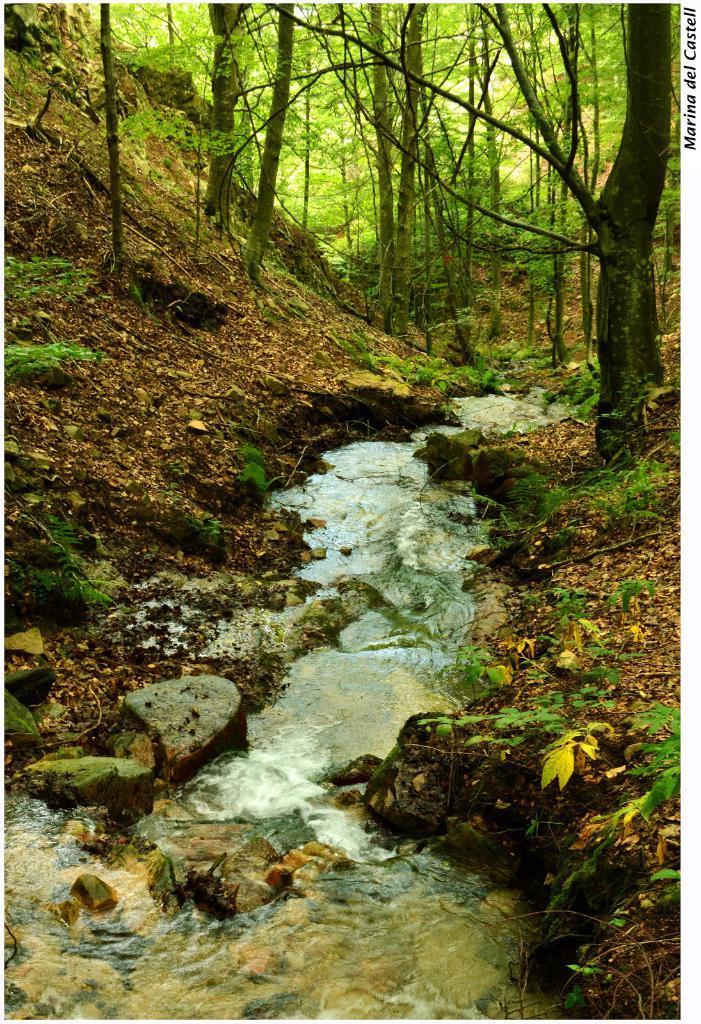Please provide a concise description of this image. in this picture we can see trees and a sand ground and there is a water flowing in between this land and here are some rocks. 